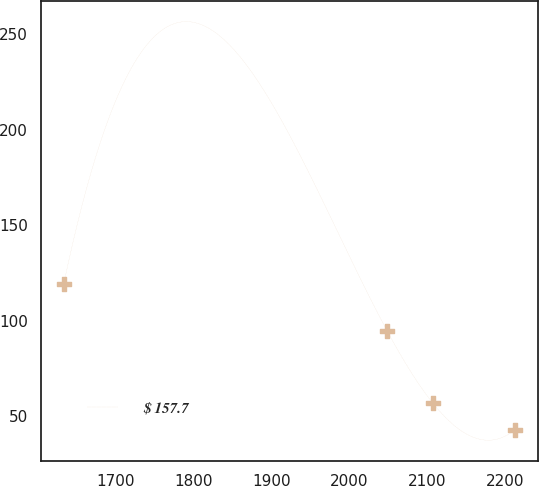<chart> <loc_0><loc_0><loc_500><loc_500><line_chart><ecel><fcel>$ 157.7<nl><fcel>1632.99<fcel>119.3<nl><fcel>2048.76<fcel>94.38<nl><fcel>2106.72<fcel>57.04<nl><fcel>2212.54<fcel>42.91<nl></chart> 